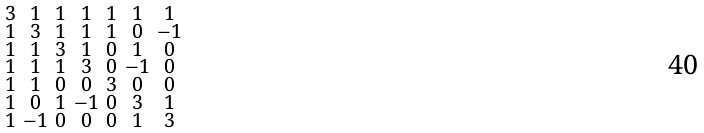<formula> <loc_0><loc_0><loc_500><loc_500>\begin{smallmatrix} 3 & 1 & 1 & 1 & 1 & 1 & 1 \\ 1 & 3 & 1 & 1 & 1 & 0 & - 1 \\ 1 & 1 & 3 & 1 & 0 & 1 & 0 \\ 1 & 1 & 1 & 3 & 0 & - 1 & 0 \\ 1 & 1 & 0 & 0 & 3 & 0 & 0 \\ 1 & 0 & 1 & - 1 & 0 & 3 & 1 \\ 1 & - 1 & 0 & 0 & 0 & 1 & 3 \end{smallmatrix}</formula> 